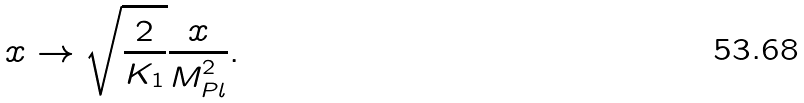Convert formula to latex. <formula><loc_0><loc_0><loc_500><loc_500>x \to \sqrt { \frac { 2 } { K _ { 1 } } } \frac { x } { M ^ { 2 } _ { P l } } .</formula> 